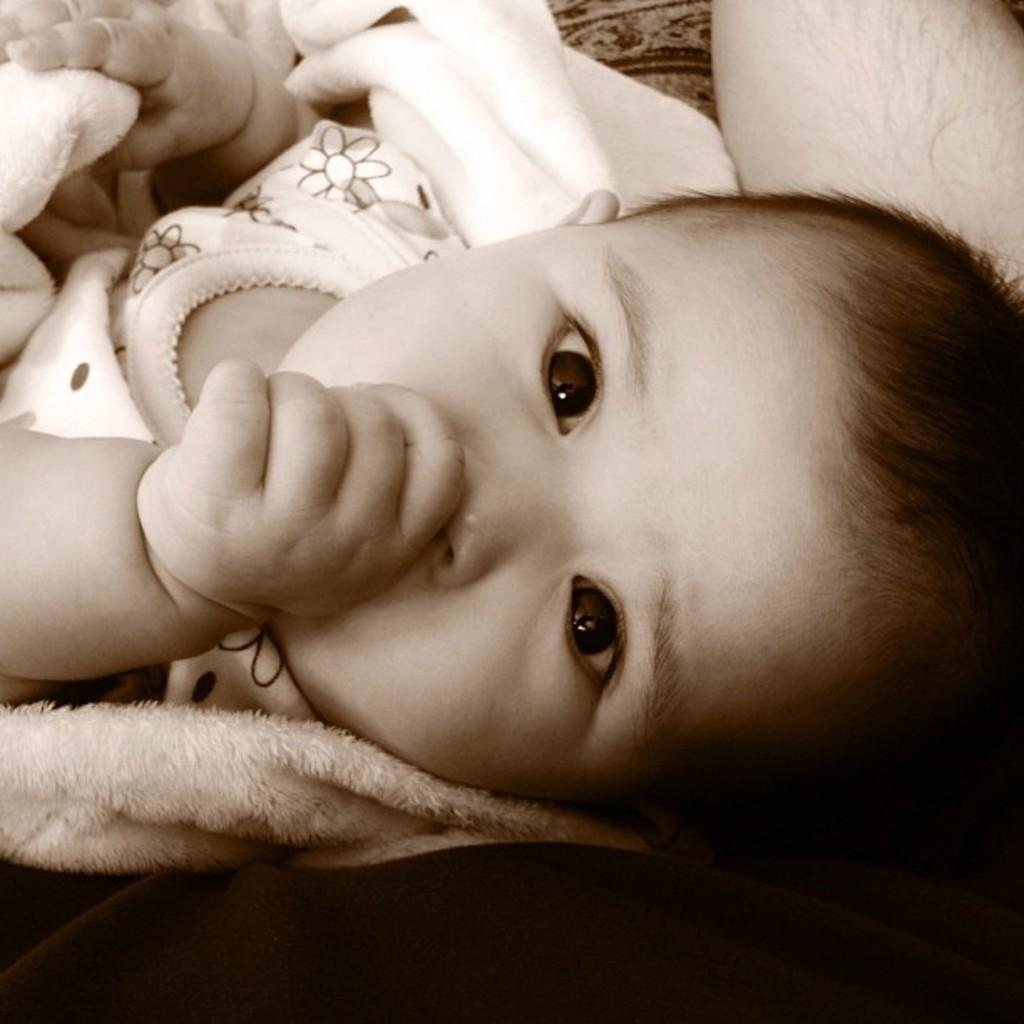What is the primary subject at the bottom of the image? There is a person sitting at the bottom of the image. What is the person holding? The person is holding a baby. Where is the faucet located in the image? There is no faucet present in the image. Is the person swimming with the baby in the image? The image does not depict the person swimming with the baby; they are sitting at the bottom of the image. 